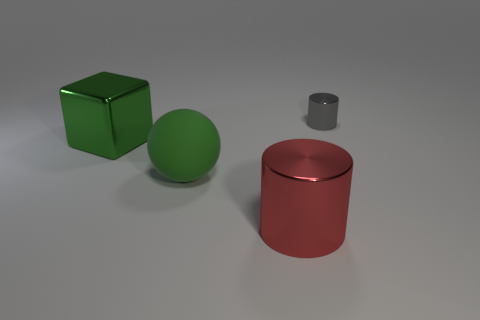Subtract all blocks. How many objects are left? 3 Subtract 1 blocks. How many blocks are left? 0 Add 4 red metal cylinders. How many red metal cylinders exist? 5 Add 4 large green rubber objects. How many objects exist? 8 Subtract 0 brown balls. How many objects are left? 4 Subtract all gray balls. Subtract all brown cylinders. How many balls are left? 1 Subtract all cyan blocks. How many gray cylinders are left? 1 Subtract all small green cubes. Subtract all large red things. How many objects are left? 3 Add 1 small gray metallic cylinders. How many small gray metallic cylinders are left? 2 